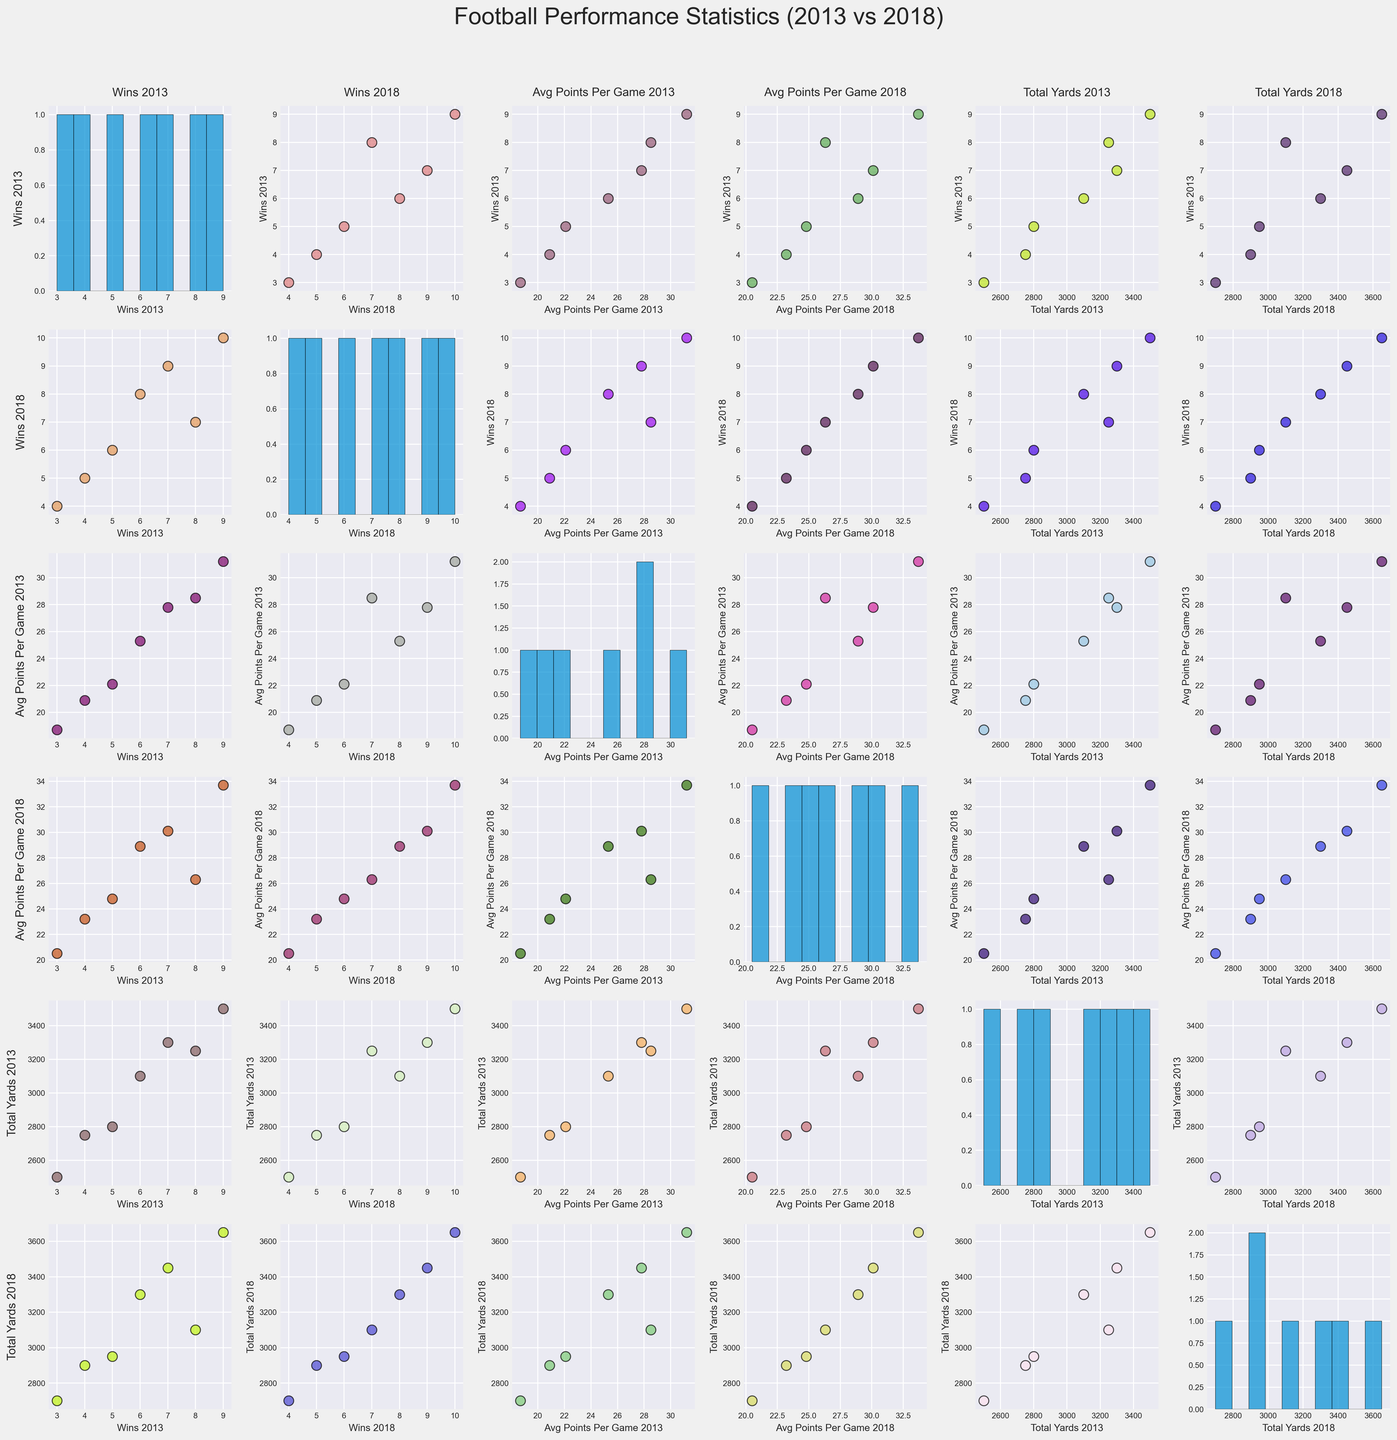How many wins did the Oak Ridge Wildcats have in 2013? Look at the scatter plot or histogram with Wins_2013 on one of the axes and identify the point or histogram bin representing the Oak Ridge Wildcats.
Answer: 8 Which team had the highest total yards in 2018? Look for the scatter plot or histogram with Total_Yards_2018 on one axis and identify the team with the highest value.
Answer: Anderson County Mavericks What is the average of wins in 2013 and 2018 for Powell Panthers? Find Powell Panthers on the scatter plots or histograms for Wins_2013 and Wins_2018. Add the two values and divide by 2. (Wins_2013 = 6, Wins_2018 = 8, (6 + 8)/2 = 7)
Answer: 7 Between 2013 and 2018, which team showed the biggest improvement in average points per game? Compare the values of Avg_Points_Per_Game_2013 and Avg_Points_Per_Game_2018 for all teams to identify which team has the largest increase. Anderson County Mavericks went from 31.2 to 33.7, showing the biggest improvement.
Answer: Anderson County Mavericks How do the number of wins in 2013 compare to 2018 for the Halls Red Devils? Find Halls Red Devils on the scatter plots or histograms for Wins_2013 and Wins_2018. Compare the two values. (Wins_2013 = 4, Wins_2018 = 5)
Answer: 4 in 2013 and 5 in 2018 Which team's average points per game decreased from 2013 to 2018? Look at the Avg_Points_Per_Game_2013 and Avg_Points_Per_Game_2018 scatter plots to identify any team with a lower 2018 value than in 2013. Oak Ridge Wildcats' Avg_Points_Per_Game decreased from 28.5 to 26.3.
Answer: Oak Ridge Wildcats How many teams had more than 25 Average Points Per Game in both 2013 and 2018? Check the scatter plots for Avg_Points_Per_Game_2013 and Avg_Points_Per_Game_2018 to count teams with values above 25 in both years. There are three teams (Oak Ridge Wildcats, Anderson County Mavericks, Central Bobcats).
Answer: 3 In terms of total yards, which team had the highest improvement from 2013 to 2018? Look at the scatter plots or histograms for Total_Yards_2013 and Total_Yards_2018 and calculate the difference for each team. Anderson County Mavericks improved the most, from 3500 to 3650 yards.
Answer: Anderson County Mavericks 